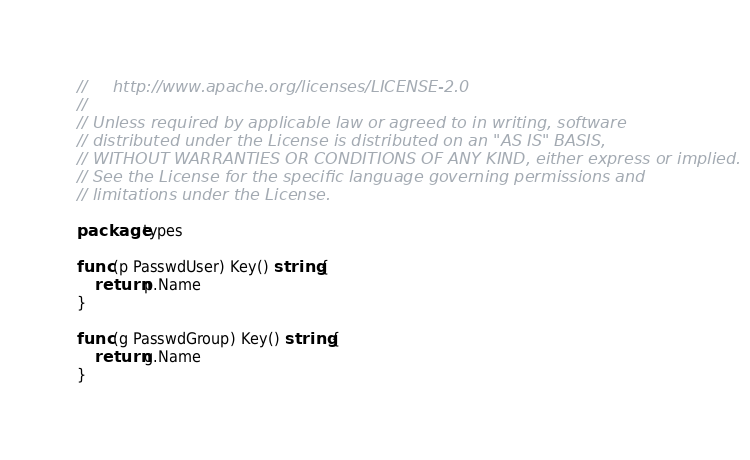Convert code to text. <code><loc_0><loc_0><loc_500><loc_500><_Go_>//     http://www.apache.org/licenses/LICENSE-2.0
//
// Unless required by applicable law or agreed to in writing, software
// distributed under the License is distributed on an "AS IS" BASIS,
// WITHOUT WARRANTIES OR CONDITIONS OF ANY KIND, either express or implied.
// See the License for the specific language governing permissions and
// limitations under the License.

package types

func (p PasswdUser) Key() string {
	return p.Name
}

func (g PasswdGroup) Key() string {
	return g.Name
}
</code> 